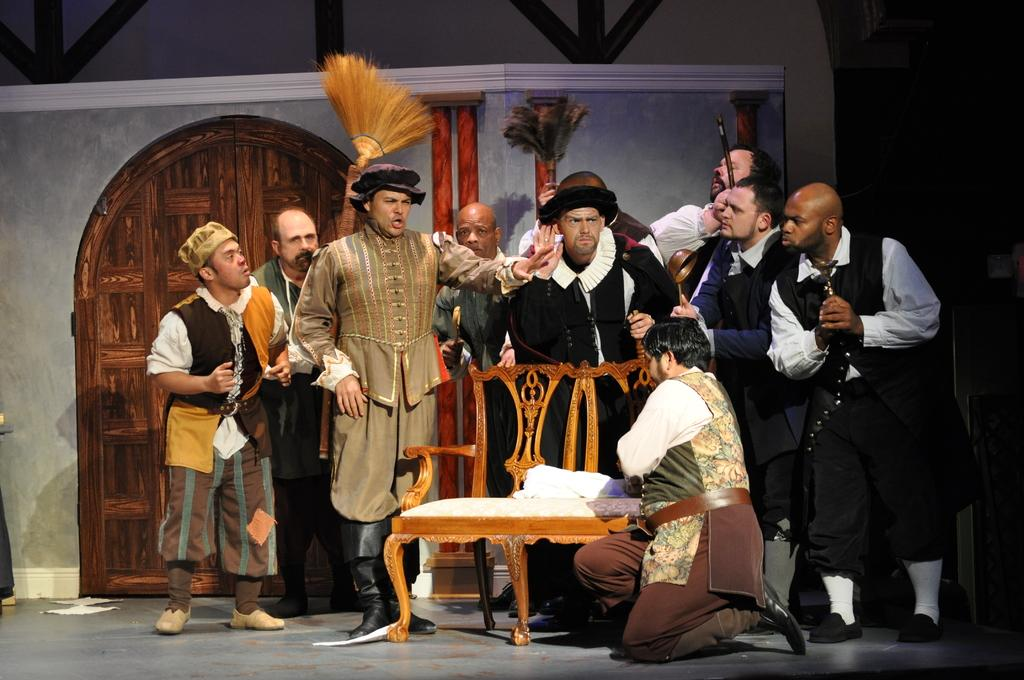How many people are in the image? There is a group of people in the image. What is one person in the group doing? One person is talking. What might the group of people be doing in the image? The group of people may be playing an act. What can be seen in the background of the image? There is a door visible in the background of the image. What type of crime is being committed in the image? There is no crime being committed in the image; it features a group of people who may be playing an act. How many roses are present in the image? There are no roses visible in the image. 